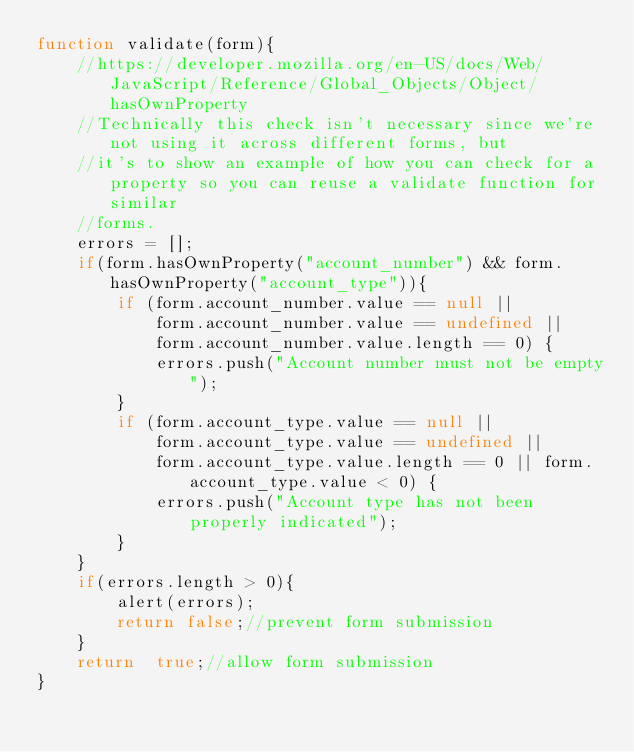Convert code to text. <code><loc_0><loc_0><loc_500><loc_500><_JavaScript_>function validate(form){
    //https://developer.mozilla.org/en-US/docs/Web/JavaScript/Reference/Global_Objects/Object/hasOwnProperty
    //Technically this check isn't necessary since we're not using it across different forms, but
    //it's to show an example of how you can check for a property so you can reuse a validate function for similar
    //forms.
    errors = [];
    if(form.hasOwnProperty("account_number") && form.hasOwnProperty("account_type")){
        if (form.account_number.value == null ||
            form.account_number.value == undefined ||
            form.account_number.value.length == 0) {
            errors.push("Account number must not be empty");
        }
        if (form.account_type.value == null ||
            form.account_type.value == undefined ||
            form.account_type.value.length == 0 || form.account_type.value < 0) {
            errors.push("Account type has not been properly indicated");
        }
    }
    if(errors.length > 0){
        alert(errors);
        return false;//prevent form submission
    }
    return  true;//allow form submission
}</code> 